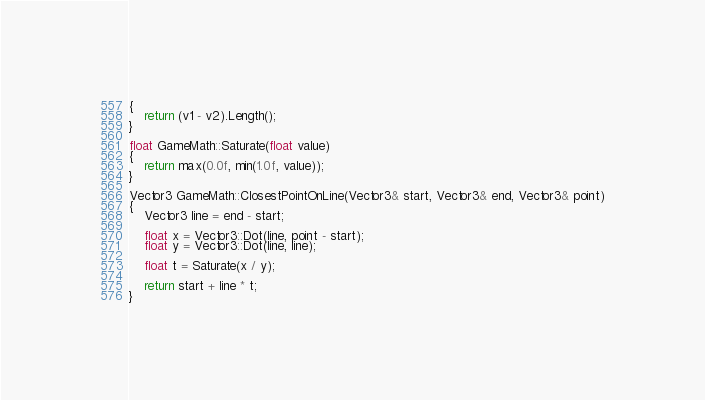Convert code to text. <code><loc_0><loc_0><loc_500><loc_500><_C++_>{
	return (v1 - v2).Length();
}

float GameMath::Saturate(float value)
{
	return max(0.0f, min(1.0f, value));
}

Vector3 GameMath::ClosestPointOnLine(Vector3& start, Vector3& end, Vector3& point)
{
	Vector3 line = end - start;

	float x = Vector3::Dot(line, point - start);
	float y = Vector3::Dot(line, line);

	float t = Saturate(x / y);

	return start + line * t;
}
</code> 